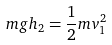<formula> <loc_0><loc_0><loc_500><loc_500>m g h _ { 2 } = \frac { 1 } { 2 } m v _ { 1 } ^ { 2 }</formula> 